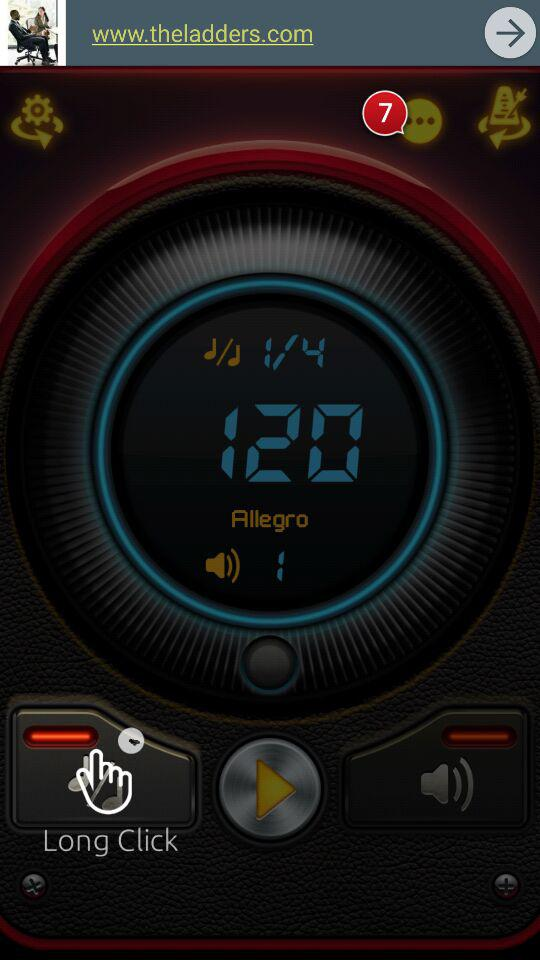What is the level of volume? The level of volume is 1. 